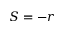<formula> <loc_0><loc_0><loc_500><loc_500>S = - r</formula> 